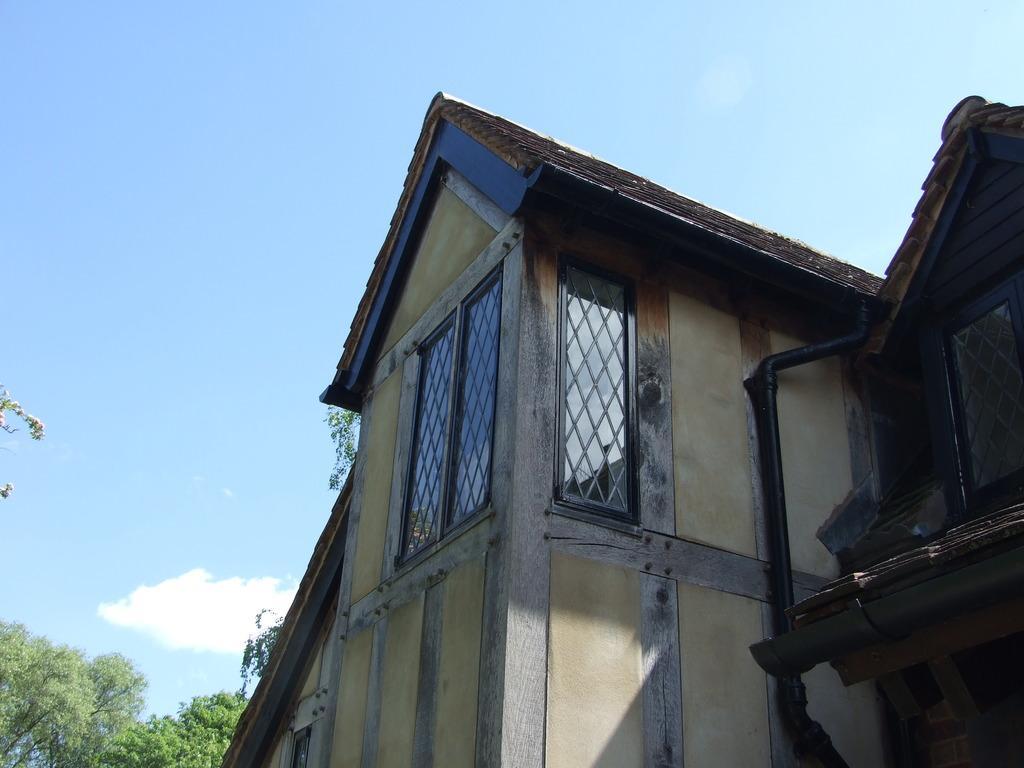Can you describe this image briefly? In the image in the center, we can see the sky, clouds, trees, one building, wall, roof and windows. 